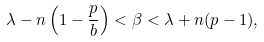Convert formula to latex. <formula><loc_0><loc_0><loc_500><loc_500>\lambda - n \left ( 1 - \frac { p } { b } \right ) < \beta < \lambda + n ( p - 1 ) ,</formula> 